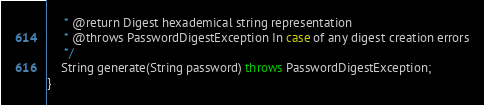Convert code to text. <code><loc_0><loc_0><loc_500><loc_500><_Java_>     * @return Digest hexademical string representation
     * @throws PasswordDigestException In case of any digest creation errors
     */
    String generate(String password) throws PasswordDigestException;
}
</code> 